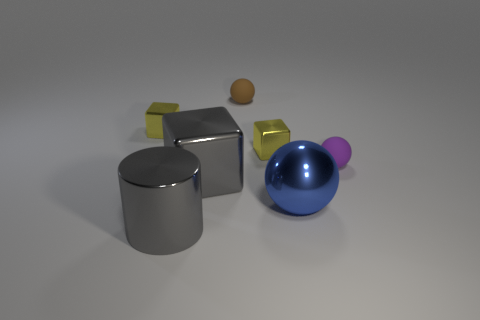There is a sphere that is behind the rubber ball that is in front of the brown sphere; are there any blue objects behind it?
Ensure brevity in your answer.  No. The large metal ball has what color?
Your answer should be compact. Blue. There is a big gray thing that is behind the blue ball; does it have the same shape as the large blue thing?
Your response must be concise. No. What number of things are gray objects or small purple rubber objects that are to the right of the gray block?
Your answer should be very brief. 3. Are the small sphere that is on the right side of the large sphere and the cylinder made of the same material?
Offer a terse response. No. Is there anything else that is the same size as the brown sphere?
Make the answer very short. Yes. What material is the small ball that is behind the small purple matte ball that is behind the blue object?
Your answer should be very brief. Rubber. Is the number of small purple rubber objects on the left side of the large blue ball greater than the number of tiny purple balls on the left side of the small brown rubber sphere?
Provide a succinct answer. No. What size is the brown ball?
Your answer should be compact. Small. Do the large metal block in front of the tiny brown object and the cylinder have the same color?
Your answer should be compact. Yes. 